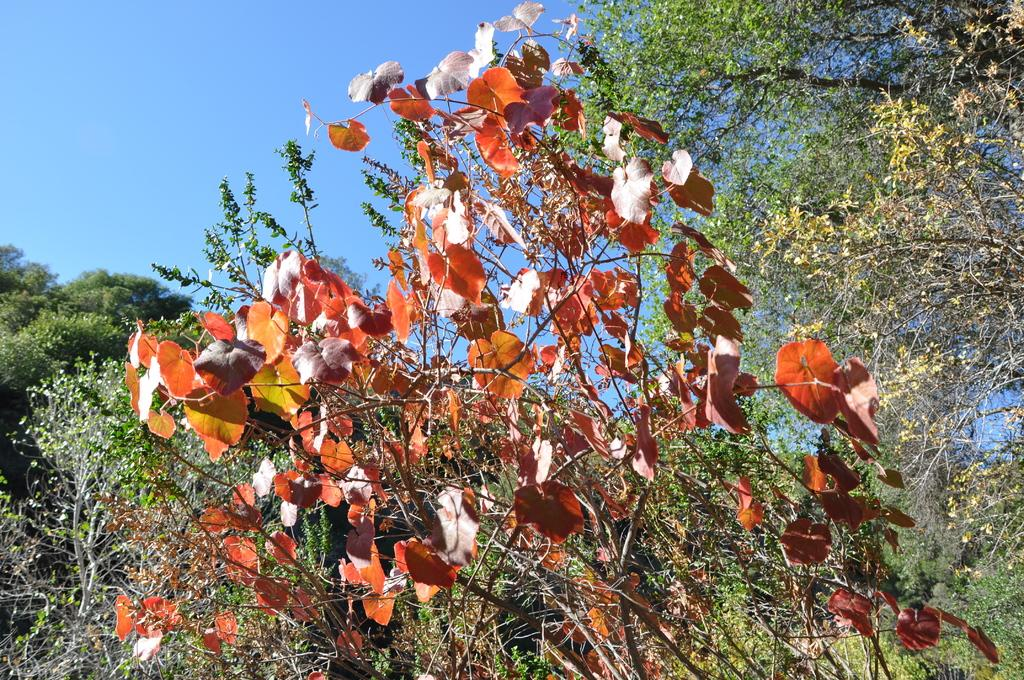What type of natural scenery can be seen in the background of the image? There are trees in the background of the image. What else is visible in the background of the image? The sky is visible in the background of the image. What hobbies are being practiced in the cellar in the image? There is no cellar or any hobbies being practiced in the image; it only features trees and the sky in the background. How many yards of fabric are visible in the image? There is no fabric or yard measurement present in the image. 